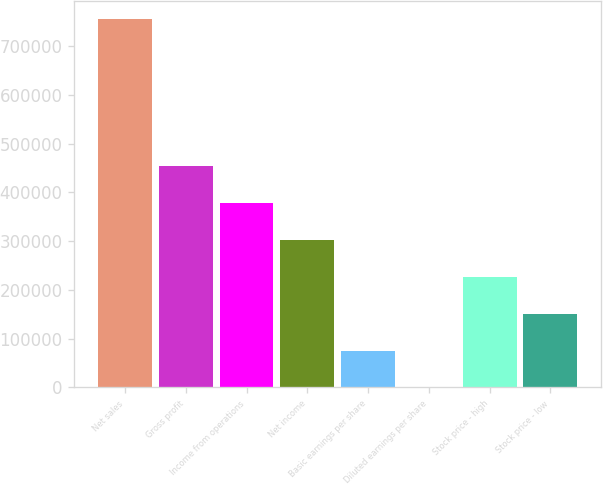Convert chart to OTSL. <chart><loc_0><loc_0><loc_500><loc_500><bar_chart><fcel>Net sales<fcel>Gross profit<fcel>Income from operations<fcel>Net income<fcel>Basic earnings per share<fcel>Diluted earnings per share<fcel>Stock price - high<fcel>Stock price - low<nl><fcel>755207<fcel>453124<fcel>377604<fcel>302083<fcel>75521.3<fcel>0.62<fcel>226563<fcel>151042<nl></chart> 